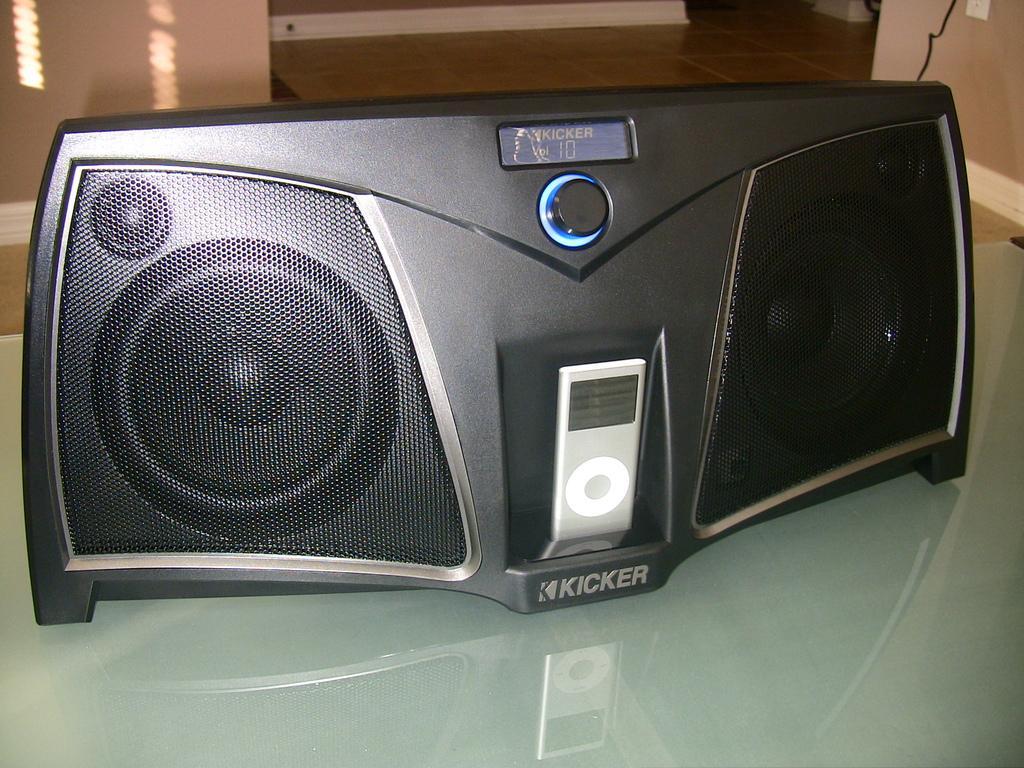Can you describe this image briefly? In this image, we can see a black color speaker kept on the glass table, in the background, we can see the floor and there is a wall. 